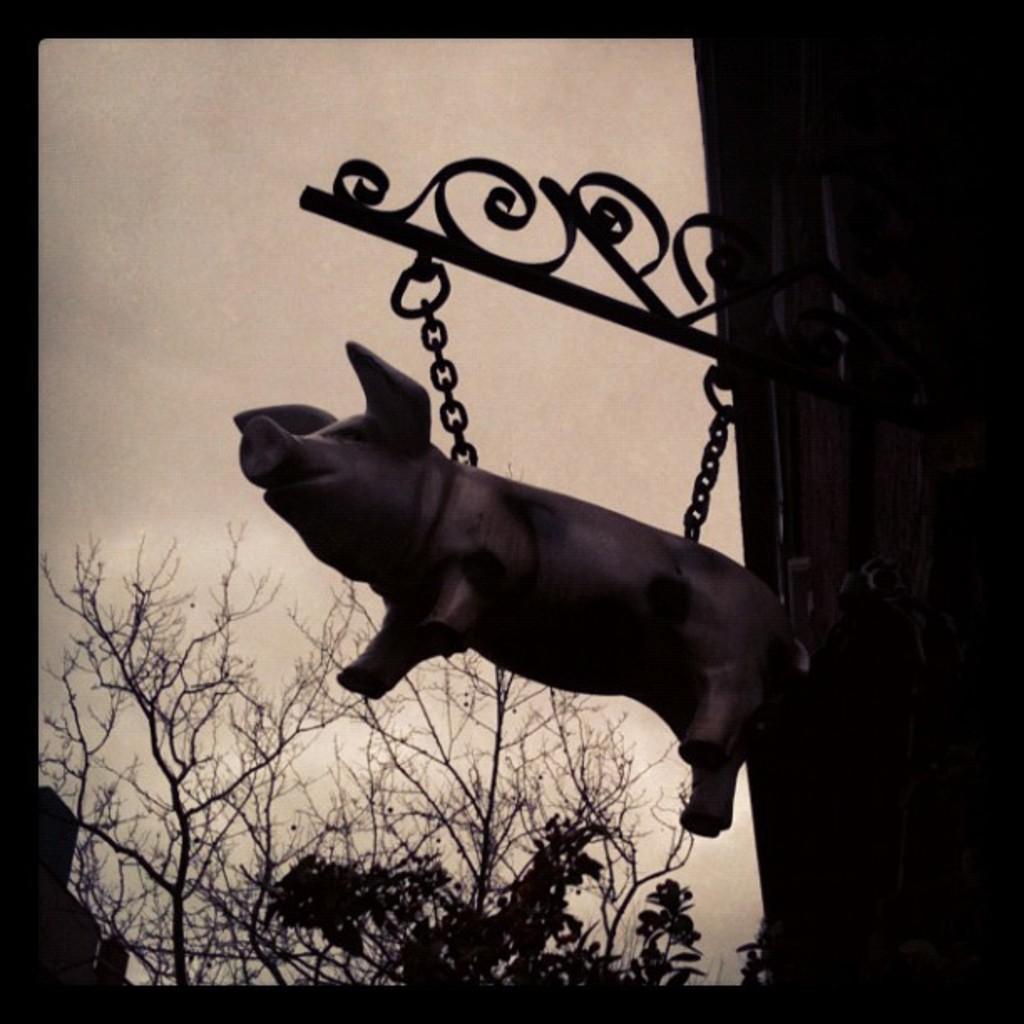How would you summarize this image in a sentence or two? In this picture we can see a sculpture of a pig and chains in the front, in the background there are some trees, we can see the sky at the top of the picture. 